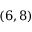<formula> <loc_0><loc_0><loc_500><loc_500>( 6 , 8 )</formula> 